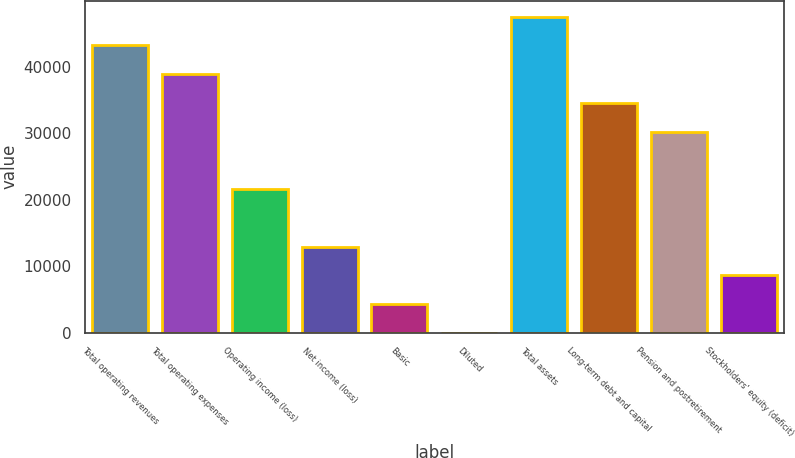Convert chart. <chart><loc_0><loc_0><loc_500><loc_500><bar_chart><fcel>Total operating revenues<fcel>Total operating expenses<fcel>Operating income (loss)<fcel>Net income (loss)<fcel>Basic<fcel>Diluted<fcel>Total assets<fcel>Long-term debt and capital<fcel>Pension and postretirement<fcel>Stockholders' equity (deficit)<nl><fcel>43225<fcel>38902.9<fcel>21614.5<fcel>12970.3<fcel>4326.04<fcel>3.93<fcel>47547.1<fcel>34580.8<fcel>30258.7<fcel>8648.15<nl></chart> 